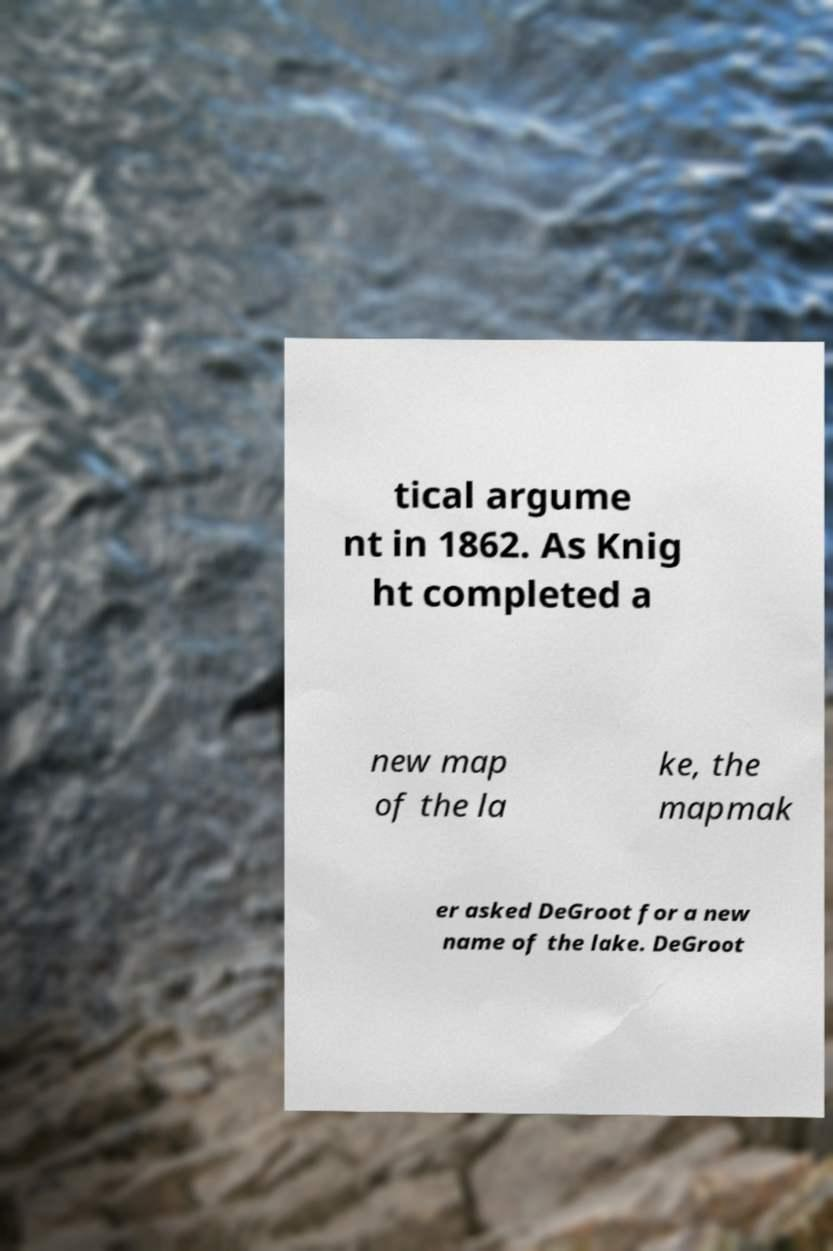Could you extract and type out the text from this image? tical argume nt in 1862. As Knig ht completed a new map of the la ke, the mapmak er asked DeGroot for a new name of the lake. DeGroot 